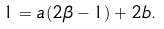<formula> <loc_0><loc_0><loc_500><loc_500>1 = a ( 2 \beta - 1 ) + 2 b .</formula> 